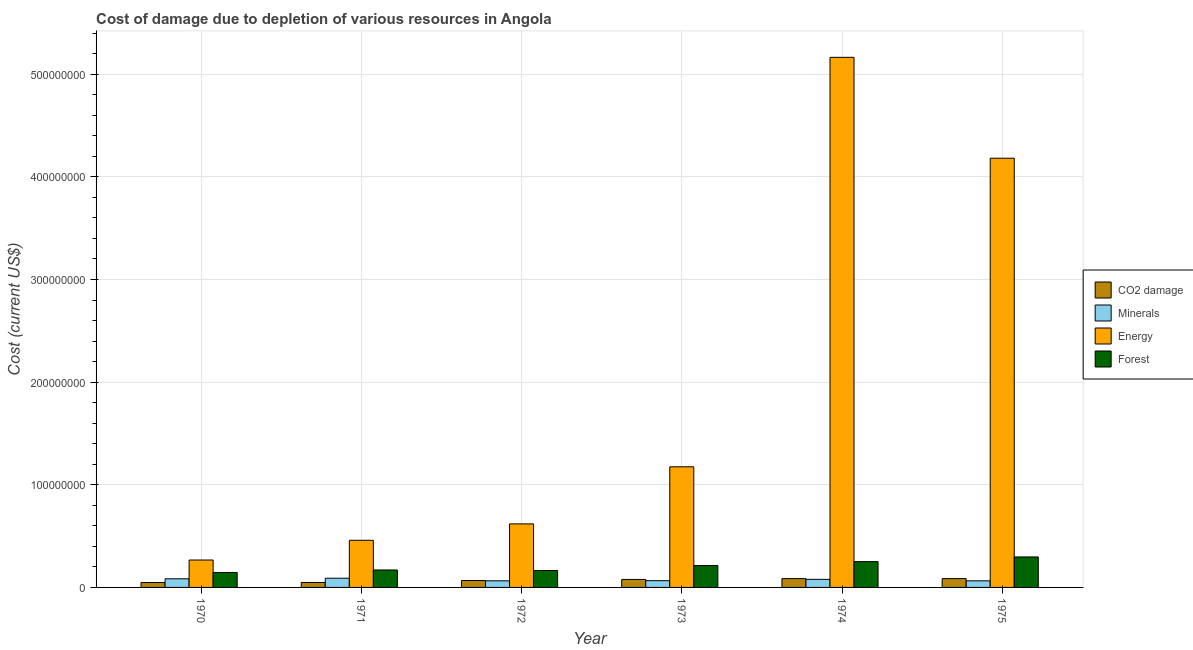How many different coloured bars are there?
Provide a succinct answer. 4. Are the number of bars per tick equal to the number of legend labels?
Your answer should be compact. Yes. Are the number of bars on each tick of the X-axis equal?
Your answer should be compact. Yes. How many bars are there on the 1st tick from the right?
Ensure brevity in your answer.  4. What is the label of the 6th group of bars from the left?
Offer a very short reply. 1975. In how many cases, is the number of bars for a given year not equal to the number of legend labels?
Offer a terse response. 0. What is the cost of damage due to depletion of minerals in 1975?
Your response must be concise. 6.41e+06. Across all years, what is the maximum cost of damage due to depletion of coal?
Make the answer very short. 8.60e+06. Across all years, what is the minimum cost of damage due to depletion of forests?
Your answer should be very brief. 1.46e+07. In which year was the cost of damage due to depletion of coal maximum?
Keep it short and to the point. 1975. In which year was the cost of damage due to depletion of coal minimum?
Offer a terse response. 1970. What is the total cost of damage due to depletion of energy in the graph?
Provide a short and direct response. 1.19e+09. What is the difference between the cost of damage due to depletion of coal in 1973 and that in 1975?
Provide a succinct answer. -8.00e+05. What is the difference between the cost of damage due to depletion of coal in 1974 and the cost of damage due to depletion of energy in 1971?
Give a very brief answer. 3.75e+06. What is the average cost of damage due to depletion of coal per year?
Make the answer very short. 6.89e+06. In the year 1974, what is the difference between the cost of damage due to depletion of energy and cost of damage due to depletion of minerals?
Offer a very short reply. 0. In how many years, is the cost of damage due to depletion of coal greater than 400000000 US$?
Offer a terse response. 0. What is the ratio of the cost of damage due to depletion of minerals in 1972 to that in 1973?
Your answer should be very brief. 0.98. Is the difference between the cost of damage due to depletion of energy in 1971 and 1974 greater than the difference between the cost of damage due to depletion of forests in 1971 and 1974?
Offer a terse response. No. What is the difference between the highest and the second highest cost of damage due to depletion of energy?
Give a very brief answer. 9.83e+07. What is the difference between the highest and the lowest cost of damage due to depletion of energy?
Offer a terse response. 4.90e+08. In how many years, is the cost of damage due to depletion of energy greater than the average cost of damage due to depletion of energy taken over all years?
Offer a very short reply. 2. Is the sum of the cost of damage due to depletion of coal in 1973 and 1975 greater than the maximum cost of damage due to depletion of energy across all years?
Make the answer very short. Yes. Is it the case that in every year, the sum of the cost of damage due to depletion of coal and cost of damage due to depletion of forests is greater than the sum of cost of damage due to depletion of energy and cost of damage due to depletion of minerals?
Provide a short and direct response. No. What does the 4th bar from the left in 1975 represents?
Provide a succinct answer. Forest. What does the 3rd bar from the right in 1970 represents?
Offer a very short reply. Minerals. Is it the case that in every year, the sum of the cost of damage due to depletion of coal and cost of damage due to depletion of minerals is greater than the cost of damage due to depletion of energy?
Offer a very short reply. No. How many years are there in the graph?
Provide a succinct answer. 6. Where does the legend appear in the graph?
Provide a short and direct response. Center right. How many legend labels are there?
Make the answer very short. 4. How are the legend labels stacked?
Ensure brevity in your answer.  Vertical. What is the title of the graph?
Offer a terse response. Cost of damage due to depletion of various resources in Angola . What is the label or title of the X-axis?
Make the answer very short. Year. What is the label or title of the Y-axis?
Make the answer very short. Cost (current US$). What is the Cost (current US$) in CO2 damage in 1970?
Offer a terse response. 4.78e+06. What is the Cost (current US$) of Minerals in 1970?
Ensure brevity in your answer.  8.42e+06. What is the Cost (current US$) of Energy in 1970?
Make the answer very short. 2.67e+07. What is the Cost (current US$) of Forest in 1970?
Give a very brief answer. 1.46e+07. What is the Cost (current US$) of CO2 damage in 1971?
Your answer should be very brief. 4.84e+06. What is the Cost (current US$) in Minerals in 1971?
Your answer should be very brief. 8.98e+06. What is the Cost (current US$) in Energy in 1971?
Give a very brief answer. 4.59e+07. What is the Cost (current US$) of Forest in 1971?
Give a very brief answer. 1.70e+07. What is the Cost (current US$) of CO2 damage in 1972?
Keep it short and to the point. 6.75e+06. What is the Cost (current US$) of Minerals in 1972?
Make the answer very short. 6.43e+06. What is the Cost (current US$) in Energy in 1972?
Ensure brevity in your answer.  6.19e+07. What is the Cost (current US$) in Forest in 1972?
Offer a terse response. 1.65e+07. What is the Cost (current US$) in CO2 damage in 1973?
Ensure brevity in your answer.  7.80e+06. What is the Cost (current US$) in Minerals in 1973?
Your answer should be very brief. 6.57e+06. What is the Cost (current US$) in Energy in 1973?
Offer a very short reply. 1.18e+08. What is the Cost (current US$) of Forest in 1973?
Offer a very short reply. 2.13e+07. What is the Cost (current US$) in CO2 damage in 1974?
Provide a succinct answer. 8.59e+06. What is the Cost (current US$) in Minerals in 1974?
Give a very brief answer. 7.87e+06. What is the Cost (current US$) in Energy in 1974?
Your answer should be compact. 5.16e+08. What is the Cost (current US$) in Forest in 1974?
Offer a very short reply. 2.51e+07. What is the Cost (current US$) in CO2 damage in 1975?
Offer a terse response. 8.60e+06. What is the Cost (current US$) of Minerals in 1975?
Make the answer very short. 6.41e+06. What is the Cost (current US$) in Energy in 1975?
Ensure brevity in your answer.  4.18e+08. What is the Cost (current US$) in Forest in 1975?
Give a very brief answer. 2.97e+07. Across all years, what is the maximum Cost (current US$) of CO2 damage?
Provide a succinct answer. 8.60e+06. Across all years, what is the maximum Cost (current US$) of Minerals?
Provide a short and direct response. 8.98e+06. Across all years, what is the maximum Cost (current US$) of Energy?
Your answer should be compact. 5.16e+08. Across all years, what is the maximum Cost (current US$) in Forest?
Provide a succinct answer. 2.97e+07. Across all years, what is the minimum Cost (current US$) in CO2 damage?
Your answer should be very brief. 4.78e+06. Across all years, what is the minimum Cost (current US$) of Minerals?
Make the answer very short. 6.41e+06. Across all years, what is the minimum Cost (current US$) of Energy?
Your response must be concise. 2.67e+07. Across all years, what is the minimum Cost (current US$) in Forest?
Give a very brief answer. 1.46e+07. What is the total Cost (current US$) in CO2 damage in the graph?
Offer a terse response. 4.14e+07. What is the total Cost (current US$) of Minerals in the graph?
Keep it short and to the point. 4.47e+07. What is the total Cost (current US$) in Energy in the graph?
Provide a succinct answer. 1.19e+09. What is the total Cost (current US$) of Forest in the graph?
Offer a very short reply. 1.24e+08. What is the difference between the Cost (current US$) in CO2 damage in 1970 and that in 1971?
Your answer should be very brief. -5.73e+04. What is the difference between the Cost (current US$) of Minerals in 1970 and that in 1971?
Make the answer very short. -5.59e+05. What is the difference between the Cost (current US$) of Energy in 1970 and that in 1971?
Provide a succinct answer. -1.92e+07. What is the difference between the Cost (current US$) in Forest in 1970 and that in 1971?
Make the answer very short. -2.42e+06. What is the difference between the Cost (current US$) in CO2 damage in 1970 and that in 1972?
Give a very brief answer. -1.97e+06. What is the difference between the Cost (current US$) of Minerals in 1970 and that in 1972?
Your answer should be compact. 1.99e+06. What is the difference between the Cost (current US$) in Energy in 1970 and that in 1972?
Your answer should be compact. -3.52e+07. What is the difference between the Cost (current US$) in Forest in 1970 and that in 1972?
Offer a terse response. -1.89e+06. What is the difference between the Cost (current US$) of CO2 damage in 1970 and that in 1973?
Make the answer very short. -3.02e+06. What is the difference between the Cost (current US$) in Minerals in 1970 and that in 1973?
Give a very brief answer. 1.85e+06. What is the difference between the Cost (current US$) of Energy in 1970 and that in 1973?
Provide a short and direct response. -9.08e+07. What is the difference between the Cost (current US$) of Forest in 1970 and that in 1973?
Offer a terse response. -6.74e+06. What is the difference between the Cost (current US$) in CO2 damage in 1970 and that in 1974?
Provide a short and direct response. -3.80e+06. What is the difference between the Cost (current US$) of Minerals in 1970 and that in 1974?
Your response must be concise. 5.56e+05. What is the difference between the Cost (current US$) of Energy in 1970 and that in 1974?
Your answer should be very brief. -4.90e+08. What is the difference between the Cost (current US$) of Forest in 1970 and that in 1974?
Your answer should be compact. -1.05e+07. What is the difference between the Cost (current US$) of CO2 damage in 1970 and that in 1975?
Your response must be concise. -3.82e+06. What is the difference between the Cost (current US$) in Minerals in 1970 and that in 1975?
Provide a succinct answer. 2.01e+06. What is the difference between the Cost (current US$) of Energy in 1970 and that in 1975?
Your answer should be very brief. -3.91e+08. What is the difference between the Cost (current US$) in Forest in 1970 and that in 1975?
Provide a short and direct response. -1.51e+07. What is the difference between the Cost (current US$) in CO2 damage in 1971 and that in 1972?
Give a very brief answer. -1.91e+06. What is the difference between the Cost (current US$) of Minerals in 1971 and that in 1972?
Keep it short and to the point. 2.55e+06. What is the difference between the Cost (current US$) in Energy in 1971 and that in 1972?
Provide a short and direct response. -1.60e+07. What is the difference between the Cost (current US$) in Forest in 1971 and that in 1972?
Give a very brief answer. 5.24e+05. What is the difference between the Cost (current US$) of CO2 damage in 1971 and that in 1973?
Your answer should be compact. -2.96e+06. What is the difference between the Cost (current US$) in Minerals in 1971 and that in 1973?
Ensure brevity in your answer.  2.41e+06. What is the difference between the Cost (current US$) in Energy in 1971 and that in 1973?
Your answer should be compact. -7.16e+07. What is the difference between the Cost (current US$) in Forest in 1971 and that in 1973?
Your response must be concise. -4.33e+06. What is the difference between the Cost (current US$) of CO2 damage in 1971 and that in 1974?
Your answer should be compact. -3.75e+06. What is the difference between the Cost (current US$) of Minerals in 1971 and that in 1974?
Give a very brief answer. 1.12e+06. What is the difference between the Cost (current US$) of Energy in 1971 and that in 1974?
Keep it short and to the point. -4.71e+08. What is the difference between the Cost (current US$) of Forest in 1971 and that in 1974?
Keep it short and to the point. -8.12e+06. What is the difference between the Cost (current US$) of CO2 damage in 1971 and that in 1975?
Your response must be concise. -3.76e+06. What is the difference between the Cost (current US$) of Minerals in 1971 and that in 1975?
Your answer should be very brief. 2.57e+06. What is the difference between the Cost (current US$) in Energy in 1971 and that in 1975?
Provide a succinct answer. -3.72e+08. What is the difference between the Cost (current US$) in Forest in 1971 and that in 1975?
Provide a short and direct response. -1.27e+07. What is the difference between the Cost (current US$) of CO2 damage in 1972 and that in 1973?
Provide a short and direct response. -1.05e+06. What is the difference between the Cost (current US$) of Minerals in 1972 and that in 1973?
Ensure brevity in your answer.  -1.45e+05. What is the difference between the Cost (current US$) in Energy in 1972 and that in 1973?
Ensure brevity in your answer.  -5.56e+07. What is the difference between the Cost (current US$) of Forest in 1972 and that in 1973?
Keep it short and to the point. -4.85e+06. What is the difference between the Cost (current US$) in CO2 damage in 1972 and that in 1974?
Your answer should be very brief. -1.84e+06. What is the difference between the Cost (current US$) in Minerals in 1972 and that in 1974?
Your answer should be compact. -1.44e+06. What is the difference between the Cost (current US$) in Energy in 1972 and that in 1974?
Provide a short and direct response. -4.55e+08. What is the difference between the Cost (current US$) in Forest in 1972 and that in 1974?
Keep it short and to the point. -8.65e+06. What is the difference between the Cost (current US$) in CO2 damage in 1972 and that in 1975?
Your response must be concise. -1.85e+06. What is the difference between the Cost (current US$) of Minerals in 1972 and that in 1975?
Offer a terse response. 1.51e+04. What is the difference between the Cost (current US$) of Energy in 1972 and that in 1975?
Give a very brief answer. -3.56e+08. What is the difference between the Cost (current US$) of Forest in 1972 and that in 1975?
Your answer should be compact. -1.32e+07. What is the difference between the Cost (current US$) in CO2 damage in 1973 and that in 1974?
Provide a short and direct response. -7.88e+05. What is the difference between the Cost (current US$) of Minerals in 1973 and that in 1974?
Keep it short and to the point. -1.29e+06. What is the difference between the Cost (current US$) of Energy in 1973 and that in 1974?
Your response must be concise. -3.99e+08. What is the difference between the Cost (current US$) in Forest in 1973 and that in 1974?
Your answer should be very brief. -3.80e+06. What is the difference between the Cost (current US$) in CO2 damage in 1973 and that in 1975?
Your answer should be very brief. -8.00e+05. What is the difference between the Cost (current US$) of Minerals in 1973 and that in 1975?
Provide a succinct answer. 1.60e+05. What is the difference between the Cost (current US$) in Energy in 1973 and that in 1975?
Give a very brief answer. -3.01e+08. What is the difference between the Cost (current US$) of Forest in 1973 and that in 1975?
Give a very brief answer. -8.37e+06. What is the difference between the Cost (current US$) of CO2 damage in 1974 and that in 1975?
Your response must be concise. -1.27e+04. What is the difference between the Cost (current US$) in Minerals in 1974 and that in 1975?
Your answer should be compact. 1.45e+06. What is the difference between the Cost (current US$) in Energy in 1974 and that in 1975?
Provide a succinct answer. 9.83e+07. What is the difference between the Cost (current US$) of Forest in 1974 and that in 1975?
Make the answer very short. -4.57e+06. What is the difference between the Cost (current US$) in CO2 damage in 1970 and the Cost (current US$) in Minerals in 1971?
Offer a terse response. -4.20e+06. What is the difference between the Cost (current US$) of CO2 damage in 1970 and the Cost (current US$) of Energy in 1971?
Give a very brief answer. -4.11e+07. What is the difference between the Cost (current US$) of CO2 damage in 1970 and the Cost (current US$) of Forest in 1971?
Keep it short and to the point. -1.22e+07. What is the difference between the Cost (current US$) in Minerals in 1970 and the Cost (current US$) in Energy in 1971?
Make the answer very short. -3.75e+07. What is the difference between the Cost (current US$) in Minerals in 1970 and the Cost (current US$) in Forest in 1971?
Give a very brief answer. -8.58e+06. What is the difference between the Cost (current US$) in Energy in 1970 and the Cost (current US$) in Forest in 1971?
Offer a very short reply. 9.69e+06. What is the difference between the Cost (current US$) of CO2 damage in 1970 and the Cost (current US$) of Minerals in 1972?
Make the answer very short. -1.65e+06. What is the difference between the Cost (current US$) of CO2 damage in 1970 and the Cost (current US$) of Energy in 1972?
Make the answer very short. -5.71e+07. What is the difference between the Cost (current US$) of CO2 damage in 1970 and the Cost (current US$) of Forest in 1972?
Your answer should be compact. -1.17e+07. What is the difference between the Cost (current US$) of Minerals in 1970 and the Cost (current US$) of Energy in 1972?
Provide a short and direct response. -5.35e+07. What is the difference between the Cost (current US$) in Minerals in 1970 and the Cost (current US$) in Forest in 1972?
Your answer should be very brief. -8.06e+06. What is the difference between the Cost (current US$) of Energy in 1970 and the Cost (current US$) of Forest in 1972?
Offer a very short reply. 1.02e+07. What is the difference between the Cost (current US$) of CO2 damage in 1970 and the Cost (current US$) of Minerals in 1973?
Offer a terse response. -1.79e+06. What is the difference between the Cost (current US$) in CO2 damage in 1970 and the Cost (current US$) in Energy in 1973?
Keep it short and to the point. -1.13e+08. What is the difference between the Cost (current US$) of CO2 damage in 1970 and the Cost (current US$) of Forest in 1973?
Provide a short and direct response. -1.65e+07. What is the difference between the Cost (current US$) in Minerals in 1970 and the Cost (current US$) in Energy in 1973?
Keep it short and to the point. -1.09e+08. What is the difference between the Cost (current US$) in Minerals in 1970 and the Cost (current US$) in Forest in 1973?
Provide a succinct answer. -1.29e+07. What is the difference between the Cost (current US$) of Energy in 1970 and the Cost (current US$) of Forest in 1973?
Your answer should be compact. 5.37e+06. What is the difference between the Cost (current US$) of CO2 damage in 1970 and the Cost (current US$) of Minerals in 1974?
Your response must be concise. -3.08e+06. What is the difference between the Cost (current US$) in CO2 damage in 1970 and the Cost (current US$) in Energy in 1974?
Your answer should be compact. -5.12e+08. What is the difference between the Cost (current US$) in CO2 damage in 1970 and the Cost (current US$) in Forest in 1974?
Offer a very short reply. -2.03e+07. What is the difference between the Cost (current US$) of Minerals in 1970 and the Cost (current US$) of Energy in 1974?
Your response must be concise. -5.08e+08. What is the difference between the Cost (current US$) in Minerals in 1970 and the Cost (current US$) in Forest in 1974?
Provide a succinct answer. -1.67e+07. What is the difference between the Cost (current US$) in Energy in 1970 and the Cost (current US$) in Forest in 1974?
Keep it short and to the point. 1.57e+06. What is the difference between the Cost (current US$) of CO2 damage in 1970 and the Cost (current US$) of Minerals in 1975?
Keep it short and to the point. -1.63e+06. What is the difference between the Cost (current US$) of CO2 damage in 1970 and the Cost (current US$) of Energy in 1975?
Give a very brief answer. -4.13e+08. What is the difference between the Cost (current US$) of CO2 damage in 1970 and the Cost (current US$) of Forest in 1975?
Offer a very short reply. -2.49e+07. What is the difference between the Cost (current US$) in Minerals in 1970 and the Cost (current US$) in Energy in 1975?
Your response must be concise. -4.10e+08. What is the difference between the Cost (current US$) of Minerals in 1970 and the Cost (current US$) of Forest in 1975?
Keep it short and to the point. -2.13e+07. What is the difference between the Cost (current US$) of Energy in 1970 and the Cost (current US$) of Forest in 1975?
Keep it short and to the point. -3.01e+06. What is the difference between the Cost (current US$) in CO2 damage in 1971 and the Cost (current US$) in Minerals in 1972?
Keep it short and to the point. -1.59e+06. What is the difference between the Cost (current US$) in CO2 damage in 1971 and the Cost (current US$) in Energy in 1972?
Your answer should be very brief. -5.71e+07. What is the difference between the Cost (current US$) of CO2 damage in 1971 and the Cost (current US$) of Forest in 1972?
Offer a very short reply. -1.16e+07. What is the difference between the Cost (current US$) in Minerals in 1971 and the Cost (current US$) in Energy in 1972?
Your response must be concise. -5.29e+07. What is the difference between the Cost (current US$) in Minerals in 1971 and the Cost (current US$) in Forest in 1972?
Keep it short and to the point. -7.50e+06. What is the difference between the Cost (current US$) of Energy in 1971 and the Cost (current US$) of Forest in 1972?
Provide a short and direct response. 2.94e+07. What is the difference between the Cost (current US$) in CO2 damage in 1971 and the Cost (current US$) in Minerals in 1973?
Offer a terse response. -1.74e+06. What is the difference between the Cost (current US$) in CO2 damage in 1971 and the Cost (current US$) in Energy in 1973?
Your response must be concise. -1.13e+08. What is the difference between the Cost (current US$) in CO2 damage in 1971 and the Cost (current US$) in Forest in 1973?
Give a very brief answer. -1.65e+07. What is the difference between the Cost (current US$) in Minerals in 1971 and the Cost (current US$) in Energy in 1973?
Keep it short and to the point. -1.09e+08. What is the difference between the Cost (current US$) of Minerals in 1971 and the Cost (current US$) of Forest in 1973?
Keep it short and to the point. -1.23e+07. What is the difference between the Cost (current US$) of Energy in 1971 and the Cost (current US$) of Forest in 1973?
Give a very brief answer. 2.46e+07. What is the difference between the Cost (current US$) of CO2 damage in 1971 and the Cost (current US$) of Minerals in 1974?
Ensure brevity in your answer.  -3.03e+06. What is the difference between the Cost (current US$) in CO2 damage in 1971 and the Cost (current US$) in Energy in 1974?
Give a very brief answer. -5.12e+08. What is the difference between the Cost (current US$) in CO2 damage in 1971 and the Cost (current US$) in Forest in 1974?
Provide a short and direct response. -2.03e+07. What is the difference between the Cost (current US$) of Minerals in 1971 and the Cost (current US$) of Energy in 1974?
Your answer should be very brief. -5.07e+08. What is the difference between the Cost (current US$) in Minerals in 1971 and the Cost (current US$) in Forest in 1974?
Provide a succinct answer. -1.61e+07. What is the difference between the Cost (current US$) in Energy in 1971 and the Cost (current US$) in Forest in 1974?
Give a very brief answer. 2.08e+07. What is the difference between the Cost (current US$) in CO2 damage in 1971 and the Cost (current US$) in Minerals in 1975?
Provide a succinct answer. -1.57e+06. What is the difference between the Cost (current US$) in CO2 damage in 1971 and the Cost (current US$) in Energy in 1975?
Your response must be concise. -4.13e+08. What is the difference between the Cost (current US$) of CO2 damage in 1971 and the Cost (current US$) of Forest in 1975?
Make the answer very short. -2.49e+07. What is the difference between the Cost (current US$) of Minerals in 1971 and the Cost (current US$) of Energy in 1975?
Offer a terse response. -4.09e+08. What is the difference between the Cost (current US$) of Minerals in 1971 and the Cost (current US$) of Forest in 1975?
Keep it short and to the point. -2.07e+07. What is the difference between the Cost (current US$) of Energy in 1971 and the Cost (current US$) of Forest in 1975?
Provide a succinct answer. 1.62e+07. What is the difference between the Cost (current US$) of CO2 damage in 1972 and the Cost (current US$) of Minerals in 1973?
Provide a succinct answer. 1.76e+05. What is the difference between the Cost (current US$) in CO2 damage in 1972 and the Cost (current US$) in Energy in 1973?
Your answer should be very brief. -1.11e+08. What is the difference between the Cost (current US$) of CO2 damage in 1972 and the Cost (current US$) of Forest in 1973?
Make the answer very short. -1.46e+07. What is the difference between the Cost (current US$) of Minerals in 1972 and the Cost (current US$) of Energy in 1973?
Offer a terse response. -1.11e+08. What is the difference between the Cost (current US$) of Minerals in 1972 and the Cost (current US$) of Forest in 1973?
Offer a very short reply. -1.49e+07. What is the difference between the Cost (current US$) in Energy in 1972 and the Cost (current US$) in Forest in 1973?
Make the answer very short. 4.06e+07. What is the difference between the Cost (current US$) of CO2 damage in 1972 and the Cost (current US$) of Minerals in 1974?
Keep it short and to the point. -1.11e+06. What is the difference between the Cost (current US$) in CO2 damage in 1972 and the Cost (current US$) in Energy in 1974?
Your answer should be very brief. -5.10e+08. What is the difference between the Cost (current US$) in CO2 damage in 1972 and the Cost (current US$) in Forest in 1974?
Provide a succinct answer. -1.84e+07. What is the difference between the Cost (current US$) of Minerals in 1972 and the Cost (current US$) of Energy in 1974?
Offer a terse response. -5.10e+08. What is the difference between the Cost (current US$) in Minerals in 1972 and the Cost (current US$) in Forest in 1974?
Your response must be concise. -1.87e+07. What is the difference between the Cost (current US$) of Energy in 1972 and the Cost (current US$) of Forest in 1974?
Provide a short and direct response. 3.68e+07. What is the difference between the Cost (current US$) in CO2 damage in 1972 and the Cost (current US$) in Minerals in 1975?
Provide a short and direct response. 3.36e+05. What is the difference between the Cost (current US$) of CO2 damage in 1972 and the Cost (current US$) of Energy in 1975?
Your answer should be compact. -4.11e+08. What is the difference between the Cost (current US$) in CO2 damage in 1972 and the Cost (current US$) in Forest in 1975?
Your response must be concise. -2.30e+07. What is the difference between the Cost (current US$) in Minerals in 1972 and the Cost (current US$) in Energy in 1975?
Provide a succinct answer. -4.12e+08. What is the difference between the Cost (current US$) in Minerals in 1972 and the Cost (current US$) in Forest in 1975?
Your answer should be very brief. -2.33e+07. What is the difference between the Cost (current US$) in Energy in 1972 and the Cost (current US$) in Forest in 1975?
Provide a short and direct response. 3.22e+07. What is the difference between the Cost (current US$) in CO2 damage in 1973 and the Cost (current US$) in Minerals in 1974?
Keep it short and to the point. -6.62e+04. What is the difference between the Cost (current US$) of CO2 damage in 1973 and the Cost (current US$) of Energy in 1974?
Your answer should be compact. -5.09e+08. What is the difference between the Cost (current US$) of CO2 damage in 1973 and the Cost (current US$) of Forest in 1974?
Offer a very short reply. -1.73e+07. What is the difference between the Cost (current US$) in Minerals in 1973 and the Cost (current US$) in Energy in 1974?
Your response must be concise. -5.10e+08. What is the difference between the Cost (current US$) of Minerals in 1973 and the Cost (current US$) of Forest in 1974?
Your response must be concise. -1.86e+07. What is the difference between the Cost (current US$) in Energy in 1973 and the Cost (current US$) in Forest in 1974?
Offer a very short reply. 9.24e+07. What is the difference between the Cost (current US$) in CO2 damage in 1973 and the Cost (current US$) in Minerals in 1975?
Give a very brief answer. 1.39e+06. What is the difference between the Cost (current US$) in CO2 damage in 1973 and the Cost (current US$) in Energy in 1975?
Offer a very short reply. -4.10e+08. What is the difference between the Cost (current US$) in CO2 damage in 1973 and the Cost (current US$) in Forest in 1975?
Provide a short and direct response. -2.19e+07. What is the difference between the Cost (current US$) of Minerals in 1973 and the Cost (current US$) of Energy in 1975?
Offer a very short reply. -4.12e+08. What is the difference between the Cost (current US$) of Minerals in 1973 and the Cost (current US$) of Forest in 1975?
Give a very brief answer. -2.31e+07. What is the difference between the Cost (current US$) of Energy in 1973 and the Cost (current US$) of Forest in 1975?
Provide a short and direct response. 8.78e+07. What is the difference between the Cost (current US$) of CO2 damage in 1974 and the Cost (current US$) of Minerals in 1975?
Offer a very short reply. 2.17e+06. What is the difference between the Cost (current US$) in CO2 damage in 1974 and the Cost (current US$) in Energy in 1975?
Your answer should be very brief. -4.10e+08. What is the difference between the Cost (current US$) in CO2 damage in 1974 and the Cost (current US$) in Forest in 1975?
Your response must be concise. -2.11e+07. What is the difference between the Cost (current US$) of Minerals in 1974 and the Cost (current US$) of Energy in 1975?
Give a very brief answer. -4.10e+08. What is the difference between the Cost (current US$) of Minerals in 1974 and the Cost (current US$) of Forest in 1975?
Give a very brief answer. -2.18e+07. What is the difference between the Cost (current US$) in Energy in 1974 and the Cost (current US$) in Forest in 1975?
Your answer should be compact. 4.87e+08. What is the average Cost (current US$) in CO2 damage per year?
Provide a succinct answer. 6.89e+06. What is the average Cost (current US$) in Minerals per year?
Offer a very short reply. 7.45e+06. What is the average Cost (current US$) in Energy per year?
Your response must be concise. 1.98e+08. What is the average Cost (current US$) in Forest per year?
Give a very brief answer. 2.07e+07. In the year 1970, what is the difference between the Cost (current US$) of CO2 damage and Cost (current US$) of Minerals?
Offer a very short reply. -3.64e+06. In the year 1970, what is the difference between the Cost (current US$) of CO2 damage and Cost (current US$) of Energy?
Ensure brevity in your answer.  -2.19e+07. In the year 1970, what is the difference between the Cost (current US$) in CO2 damage and Cost (current US$) in Forest?
Keep it short and to the point. -9.80e+06. In the year 1970, what is the difference between the Cost (current US$) in Minerals and Cost (current US$) in Energy?
Offer a terse response. -1.83e+07. In the year 1970, what is the difference between the Cost (current US$) in Minerals and Cost (current US$) in Forest?
Your answer should be compact. -6.16e+06. In the year 1970, what is the difference between the Cost (current US$) in Energy and Cost (current US$) in Forest?
Ensure brevity in your answer.  1.21e+07. In the year 1971, what is the difference between the Cost (current US$) of CO2 damage and Cost (current US$) of Minerals?
Ensure brevity in your answer.  -4.14e+06. In the year 1971, what is the difference between the Cost (current US$) of CO2 damage and Cost (current US$) of Energy?
Your answer should be very brief. -4.11e+07. In the year 1971, what is the difference between the Cost (current US$) in CO2 damage and Cost (current US$) in Forest?
Your answer should be compact. -1.22e+07. In the year 1971, what is the difference between the Cost (current US$) in Minerals and Cost (current US$) in Energy?
Make the answer very short. -3.69e+07. In the year 1971, what is the difference between the Cost (current US$) of Minerals and Cost (current US$) of Forest?
Offer a terse response. -8.02e+06. In the year 1971, what is the difference between the Cost (current US$) in Energy and Cost (current US$) in Forest?
Offer a terse response. 2.89e+07. In the year 1972, what is the difference between the Cost (current US$) in CO2 damage and Cost (current US$) in Minerals?
Your response must be concise. 3.21e+05. In the year 1972, what is the difference between the Cost (current US$) in CO2 damage and Cost (current US$) in Energy?
Your answer should be very brief. -5.52e+07. In the year 1972, what is the difference between the Cost (current US$) of CO2 damage and Cost (current US$) of Forest?
Offer a terse response. -9.73e+06. In the year 1972, what is the difference between the Cost (current US$) of Minerals and Cost (current US$) of Energy?
Your answer should be compact. -5.55e+07. In the year 1972, what is the difference between the Cost (current US$) in Minerals and Cost (current US$) in Forest?
Your answer should be very brief. -1.01e+07. In the year 1972, what is the difference between the Cost (current US$) of Energy and Cost (current US$) of Forest?
Give a very brief answer. 4.54e+07. In the year 1973, what is the difference between the Cost (current US$) of CO2 damage and Cost (current US$) of Minerals?
Offer a very short reply. 1.22e+06. In the year 1973, what is the difference between the Cost (current US$) of CO2 damage and Cost (current US$) of Energy?
Your answer should be very brief. -1.10e+08. In the year 1973, what is the difference between the Cost (current US$) in CO2 damage and Cost (current US$) in Forest?
Provide a short and direct response. -1.35e+07. In the year 1973, what is the difference between the Cost (current US$) in Minerals and Cost (current US$) in Energy?
Provide a short and direct response. -1.11e+08. In the year 1973, what is the difference between the Cost (current US$) of Minerals and Cost (current US$) of Forest?
Your answer should be very brief. -1.48e+07. In the year 1973, what is the difference between the Cost (current US$) of Energy and Cost (current US$) of Forest?
Your answer should be compact. 9.62e+07. In the year 1974, what is the difference between the Cost (current US$) in CO2 damage and Cost (current US$) in Minerals?
Keep it short and to the point. 7.21e+05. In the year 1974, what is the difference between the Cost (current US$) of CO2 damage and Cost (current US$) of Energy?
Keep it short and to the point. -5.08e+08. In the year 1974, what is the difference between the Cost (current US$) of CO2 damage and Cost (current US$) of Forest?
Keep it short and to the point. -1.65e+07. In the year 1974, what is the difference between the Cost (current US$) in Minerals and Cost (current US$) in Energy?
Ensure brevity in your answer.  -5.09e+08. In the year 1974, what is the difference between the Cost (current US$) of Minerals and Cost (current US$) of Forest?
Make the answer very short. -1.73e+07. In the year 1974, what is the difference between the Cost (current US$) of Energy and Cost (current US$) of Forest?
Provide a short and direct response. 4.91e+08. In the year 1975, what is the difference between the Cost (current US$) of CO2 damage and Cost (current US$) of Minerals?
Your response must be concise. 2.19e+06. In the year 1975, what is the difference between the Cost (current US$) in CO2 damage and Cost (current US$) in Energy?
Keep it short and to the point. -4.10e+08. In the year 1975, what is the difference between the Cost (current US$) of CO2 damage and Cost (current US$) of Forest?
Your response must be concise. -2.11e+07. In the year 1975, what is the difference between the Cost (current US$) in Minerals and Cost (current US$) in Energy?
Keep it short and to the point. -4.12e+08. In the year 1975, what is the difference between the Cost (current US$) of Minerals and Cost (current US$) of Forest?
Provide a short and direct response. -2.33e+07. In the year 1975, what is the difference between the Cost (current US$) in Energy and Cost (current US$) in Forest?
Give a very brief answer. 3.88e+08. What is the ratio of the Cost (current US$) in CO2 damage in 1970 to that in 1971?
Offer a terse response. 0.99. What is the ratio of the Cost (current US$) of Minerals in 1970 to that in 1971?
Provide a short and direct response. 0.94. What is the ratio of the Cost (current US$) in Energy in 1970 to that in 1971?
Ensure brevity in your answer.  0.58. What is the ratio of the Cost (current US$) of Forest in 1970 to that in 1971?
Provide a succinct answer. 0.86. What is the ratio of the Cost (current US$) of CO2 damage in 1970 to that in 1972?
Your answer should be compact. 0.71. What is the ratio of the Cost (current US$) of Minerals in 1970 to that in 1972?
Provide a short and direct response. 1.31. What is the ratio of the Cost (current US$) of Energy in 1970 to that in 1972?
Ensure brevity in your answer.  0.43. What is the ratio of the Cost (current US$) in Forest in 1970 to that in 1972?
Offer a very short reply. 0.89. What is the ratio of the Cost (current US$) in CO2 damage in 1970 to that in 1973?
Make the answer very short. 0.61. What is the ratio of the Cost (current US$) of Minerals in 1970 to that in 1973?
Offer a terse response. 1.28. What is the ratio of the Cost (current US$) of Energy in 1970 to that in 1973?
Offer a terse response. 0.23. What is the ratio of the Cost (current US$) of Forest in 1970 to that in 1973?
Your answer should be very brief. 0.68. What is the ratio of the Cost (current US$) in CO2 damage in 1970 to that in 1974?
Offer a very short reply. 0.56. What is the ratio of the Cost (current US$) of Minerals in 1970 to that in 1974?
Give a very brief answer. 1.07. What is the ratio of the Cost (current US$) of Energy in 1970 to that in 1974?
Make the answer very short. 0.05. What is the ratio of the Cost (current US$) of Forest in 1970 to that in 1974?
Make the answer very short. 0.58. What is the ratio of the Cost (current US$) in CO2 damage in 1970 to that in 1975?
Provide a short and direct response. 0.56. What is the ratio of the Cost (current US$) in Minerals in 1970 to that in 1975?
Your answer should be very brief. 1.31. What is the ratio of the Cost (current US$) of Energy in 1970 to that in 1975?
Provide a succinct answer. 0.06. What is the ratio of the Cost (current US$) in Forest in 1970 to that in 1975?
Your response must be concise. 0.49. What is the ratio of the Cost (current US$) in CO2 damage in 1971 to that in 1972?
Make the answer very short. 0.72. What is the ratio of the Cost (current US$) in Minerals in 1971 to that in 1972?
Ensure brevity in your answer.  1.4. What is the ratio of the Cost (current US$) of Energy in 1971 to that in 1972?
Your answer should be very brief. 0.74. What is the ratio of the Cost (current US$) in Forest in 1971 to that in 1972?
Offer a terse response. 1.03. What is the ratio of the Cost (current US$) in CO2 damage in 1971 to that in 1973?
Your answer should be very brief. 0.62. What is the ratio of the Cost (current US$) of Minerals in 1971 to that in 1973?
Offer a terse response. 1.37. What is the ratio of the Cost (current US$) in Energy in 1971 to that in 1973?
Your response must be concise. 0.39. What is the ratio of the Cost (current US$) in Forest in 1971 to that in 1973?
Provide a short and direct response. 0.8. What is the ratio of the Cost (current US$) of CO2 damage in 1971 to that in 1974?
Your response must be concise. 0.56. What is the ratio of the Cost (current US$) in Minerals in 1971 to that in 1974?
Ensure brevity in your answer.  1.14. What is the ratio of the Cost (current US$) in Energy in 1971 to that in 1974?
Give a very brief answer. 0.09. What is the ratio of the Cost (current US$) in Forest in 1971 to that in 1974?
Ensure brevity in your answer.  0.68. What is the ratio of the Cost (current US$) of CO2 damage in 1971 to that in 1975?
Your response must be concise. 0.56. What is the ratio of the Cost (current US$) of Minerals in 1971 to that in 1975?
Give a very brief answer. 1.4. What is the ratio of the Cost (current US$) in Energy in 1971 to that in 1975?
Give a very brief answer. 0.11. What is the ratio of the Cost (current US$) of Forest in 1971 to that in 1975?
Make the answer very short. 0.57. What is the ratio of the Cost (current US$) of CO2 damage in 1972 to that in 1973?
Provide a succinct answer. 0.87. What is the ratio of the Cost (current US$) in Minerals in 1972 to that in 1973?
Your answer should be compact. 0.98. What is the ratio of the Cost (current US$) of Energy in 1972 to that in 1973?
Provide a short and direct response. 0.53. What is the ratio of the Cost (current US$) in Forest in 1972 to that in 1973?
Keep it short and to the point. 0.77. What is the ratio of the Cost (current US$) of CO2 damage in 1972 to that in 1974?
Give a very brief answer. 0.79. What is the ratio of the Cost (current US$) of Minerals in 1972 to that in 1974?
Your response must be concise. 0.82. What is the ratio of the Cost (current US$) of Energy in 1972 to that in 1974?
Offer a terse response. 0.12. What is the ratio of the Cost (current US$) of Forest in 1972 to that in 1974?
Your answer should be very brief. 0.66. What is the ratio of the Cost (current US$) in CO2 damage in 1972 to that in 1975?
Provide a short and direct response. 0.79. What is the ratio of the Cost (current US$) of Minerals in 1972 to that in 1975?
Offer a very short reply. 1. What is the ratio of the Cost (current US$) in Energy in 1972 to that in 1975?
Offer a very short reply. 0.15. What is the ratio of the Cost (current US$) in Forest in 1972 to that in 1975?
Your answer should be compact. 0.55. What is the ratio of the Cost (current US$) in CO2 damage in 1973 to that in 1974?
Your answer should be compact. 0.91. What is the ratio of the Cost (current US$) of Minerals in 1973 to that in 1974?
Your answer should be very brief. 0.84. What is the ratio of the Cost (current US$) of Energy in 1973 to that in 1974?
Your answer should be very brief. 0.23. What is the ratio of the Cost (current US$) of Forest in 1973 to that in 1974?
Keep it short and to the point. 0.85. What is the ratio of the Cost (current US$) in CO2 damage in 1973 to that in 1975?
Keep it short and to the point. 0.91. What is the ratio of the Cost (current US$) in Energy in 1973 to that in 1975?
Keep it short and to the point. 0.28. What is the ratio of the Cost (current US$) of Forest in 1973 to that in 1975?
Offer a very short reply. 0.72. What is the ratio of the Cost (current US$) of Minerals in 1974 to that in 1975?
Provide a succinct answer. 1.23. What is the ratio of the Cost (current US$) in Energy in 1974 to that in 1975?
Your answer should be compact. 1.24. What is the ratio of the Cost (current US$) of Forest in 1974 to that in 1975?
Offer a very short reply. 0.85. What is the difference between the highest and the second highest Cost (current US$) of CO2 damage?
Offer a very short reply. 1.27e+04. What is the difference between the highest and the second highest Cost (current US$) in Minerals?
Offer a very short reply. 5.59e+05. What is the difference between the highest and the second highest Cost (current US$) of Energy?
Keep it short and to the point. 9.83e+07. What is the difference between the highest and the second highest Cost (current US$) in Forest?
Your response must be concise. 4.57e+06. What is the difference between the highest and the lowest Cost (current US$) in CO2 damage?
Give a very brief answer. 3.82e+06. What is the difference between the highest and the lowest Cost (current US$) in Minerals?
Provide a succinct answer. 2.57e+06. What is the difference between the highest and the lowest Cost (current US$) in Energy?
Give a very brief answer. 4.90e+08. What is the difference between the highest and the lowest Cost (current US$) of Forest?
Give a very brief answer. 1.51e+07. 